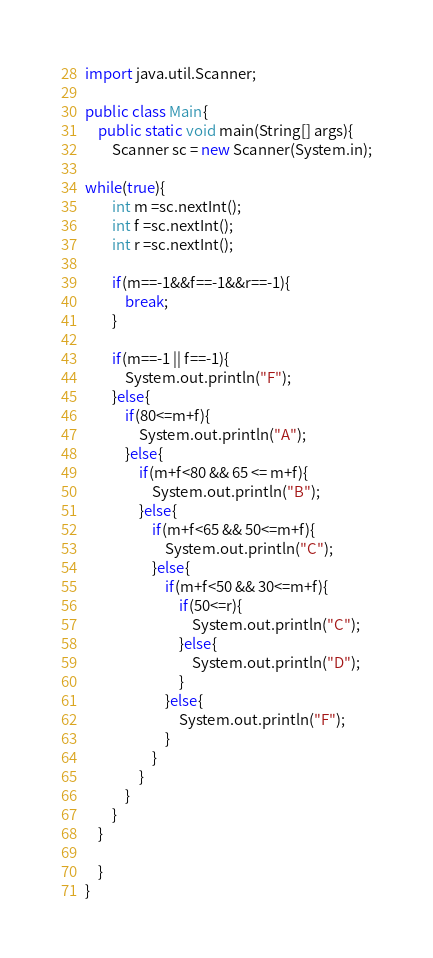<code> <loc_0><loc_0><loc_500><loc_500><_Java_>import java.util.Scanner;

public class Main{
    public static void main(String[] args){
        Scanner sc = new Scanner(System.in);

while(true){
        int m =sc.nextInt();
        int f =sc.nextInt();
        int r =sc.nextInt();

        if(m==-1&&f==-1&&r==-1){
            break;
        }

        if(m==-1 || f==-1){
            System.out.println("F");
        }else{
            if(80<=m+f){
                System.out.println("A");
            }else{
                if(m+f<80 && 65 <= m+f){
                    System.out.println("B");
                }else{
                    if(m+f<65 && 50<=m+f){
                        System.out.println("C");
                    }else{
                        if(m+f<50 && 30<=m+f){
                            if(50<=r){
                                System.out.println("C");
                            }else{
                                System.out.println("D");
                            }
                        }else{
                            System.out.println("F");
                        }
                    }
                }
            }
        }
    }

    }
}
</code> 